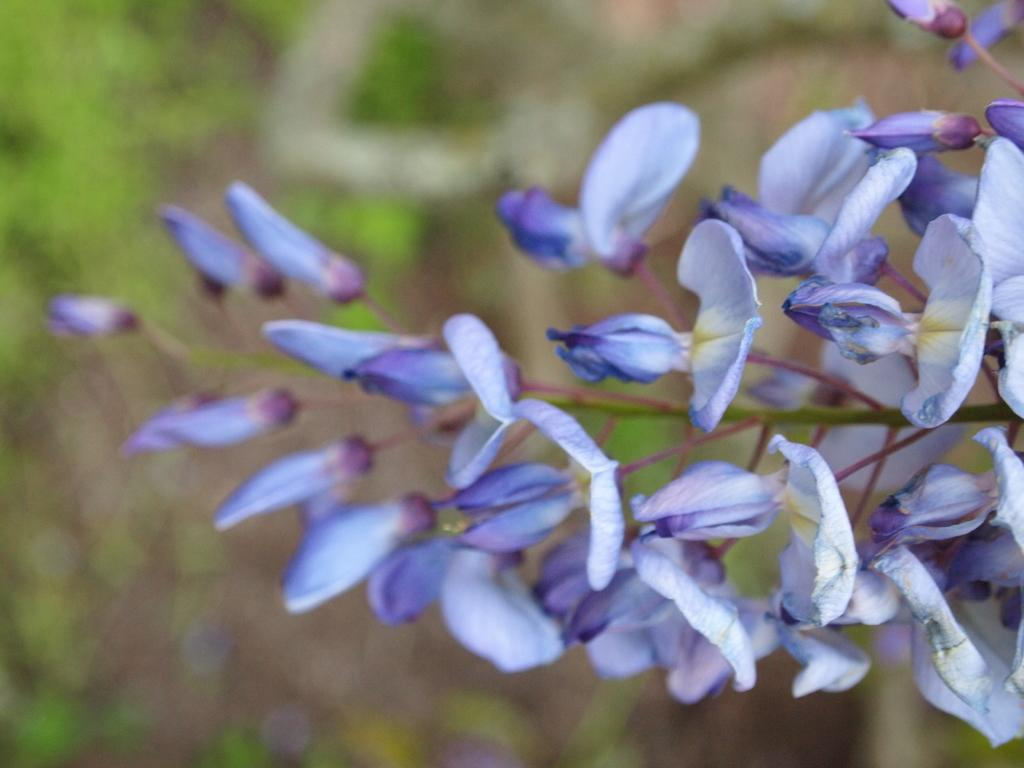What type of plant is visible in the image? There are flowers on a plant in the image. Can you describe the flowers on the plant? Unfortunately, the facts provided do not give any details about the flowers on the plant. What might be the purpose of the plant in the image? The purpose of the plant in the image is not specified, but it could be for decoration or for growing flowers. How many ducks are fighting in the garden in the image? There are no ducks or garden present in the image; it only features a plant with flowers. 